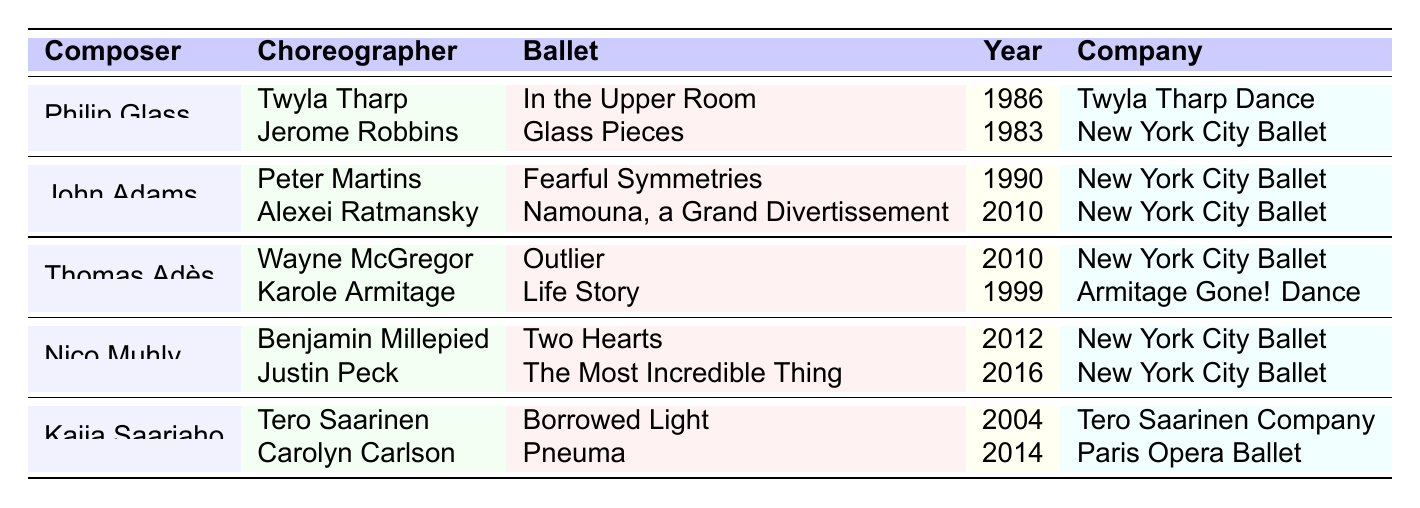What are the names of the choreographers Philip Glass collaborated with? The table lists the collaborations of Philip Glass, showing that he worked with Twyla Tharp and Jerome Robbins.
Answer: Twyla Tharp, Jerome Robbins Which ballet did John Adams create for the New York City Ballet in 1990? Referring to the table, John Adams collaborated with Peter Martins to create "Fearful Symmetries" in 1990 for New York City Ballet.
Answer: Fearful Symmetries How many ballets has Nico Muhly collaborated on with Justin Peck? The table indicates that there are two collaborations listed for Nico Muhly: one with Benjamin Millepied and another with Justin Peck. The collaboration with Justin Peck is “The Most Incredible Thing.”
Answer: One Did Thomas Adès collaborate with any choreographers from the New York City Ballet? The table shows that Thomas Adès collaborated with Wayne McGregor and Karole Armitage. Wayne McGregor is listed for New York City Ballet, confirming a collaboration with that company.
Answer: Yes What was the earliest year of collaboration listed for any composer in the table? By checking the years listed for each collaboration, the earliest year found is 1983 for the ballet "Glass Pieces" by Jerome Robbins with Philip Glass.
Answer: 1983 Which composer collaborated with both Wayne McGregor and Karole Armitage? The table identifies that Thomas Adès worked with Wayne McGregor for "Outlier" and Karole Armitage for "Life Story."
Answer: Thomas Adès How many total ballets are listed for the composer Kaija Saariaho? The table shows that Kaija Saariaho has two collaborations listed, "Borrowed Light" with Tero Saarinen and "Pneuma" with Carolyn Carlson.
Answer: Two Was "Outlier" performed by the Paris Opera Ballet? Checking the table, "Outlier" was associated with New York City Ballet, not the Paris Opera Ballet.
Answer: No Which company did Tero Saarinen collaborate with Kaija Saariaho for his ballet? The table indicates that Tero Saarinen collaborated with Kaija Saariaho for "Borrowed Light," performed by Tero Saarinen Company.
Answer: Tero Saarinen Company How many choreographers did John Adams collaborate with, and what was the last year of his collaborations? John Adams collaborated with two choreographers: Peter Martins and Alexei Ratmansky. The last collaboration noted was in 2010.
Answer: Two, 2010 